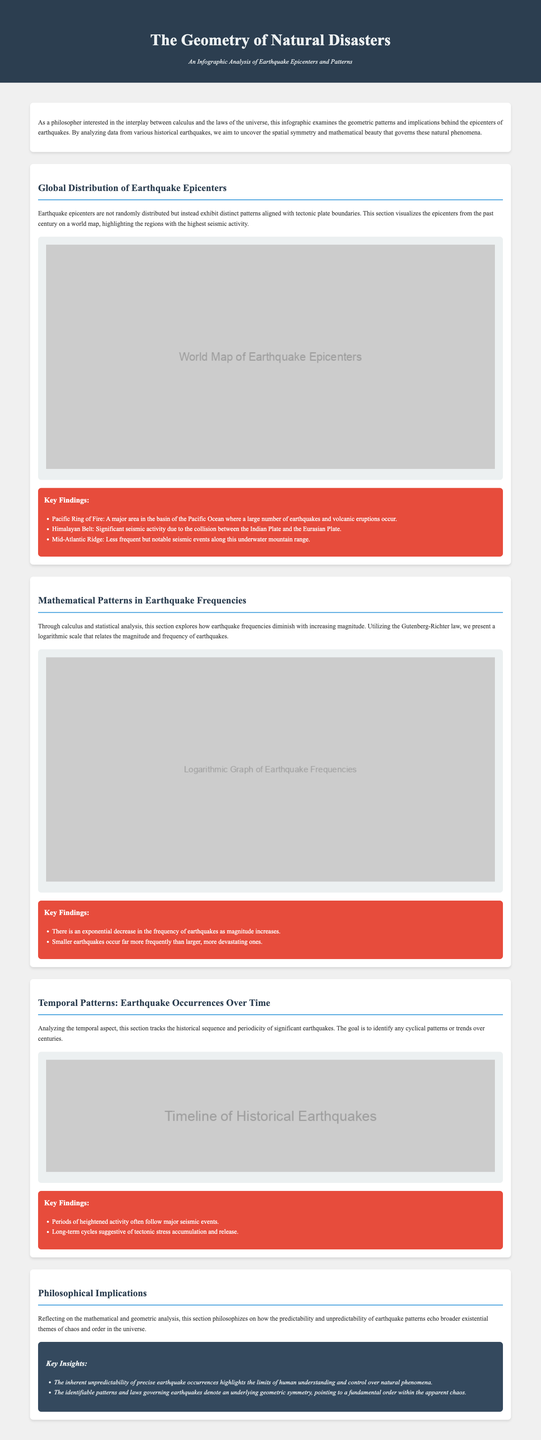What is the title of the infographic? The title is explicitly stated in the header of the document.
Answer: The Geometry of Natural Disasters What major area is highlighted for seismic activity? This is mentioned in the key findings section related to global distribution of earthquake epicenters.
Answer: Pacific Ring of Fire What logarithmic relationship is explored in the infographic? The infographic discusses a specific statistical law related to earthquake frequencies in a particular section.
Answer: Gutenberg-Richter law How are smaller earthquakes compared to larger ones? This is a key finding related to the mathematical patterns in earthquake frequencies.
Answer: More frequently What does the section on temporal patterns analyze? The section specifically discusses a certain aspect of earthquake occurrences.
Answer: Historical sequence What philosophical theme is reflected upon regarding earthquakes? The last section discusses broader philosophical themes in relation to earthquake patterns.
Answer: Chaos and order What is a significant geological event mentioned in the key findings for the Himalayan Belt? This is noted in the context of seismic activity in the document.
Answer: Collision What does the infographic suggest about long-term earthquake cycles? This is found in the key findings section regarding temporal patterns.
Answer: Tectonic stress accumulation What is one insight discussed in the philosophical implications section? This section lists key insights that reflect on mathematical analysis.
Answer: Limits of human understanding 